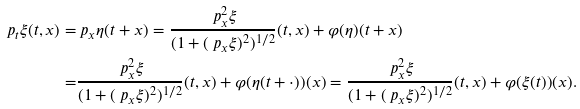Convert formula to latex. <formula><loc_0><loc_0><loc_500><loc_500>\ p _ { t } \xi ( t , x ) = & \ p _ { x } \eta ( t + x ) = \frac { \ p _ { x } ^ { 2 } \xi } { ( 1 + ( \ p _ { x } \xi ) ^ { 2 } ) ^ { 1 / 2 } } ( t , x ) + \varphi ( \eta ) ( t + x ) \\ = & \frac { \ p _ { x } ^ { 2 } \xi } { ( 1 + ( \ p _ { x } \xi ) ^ { 2 } ) ^ { 1 / 2 } } ( t , x ) + \varphi ( \eta ( t + \cdot ) ) ( x ) = \frac { \ p _ { x } ^ { 2 } \xi } { ( 1 + ( \ p _ { x } \xi ) ^ { 2 } ) ^ { 1 / 2 } } ( t , x ) + { \varphi } ( \xi ( t ) ) ( x ) .</formula> 